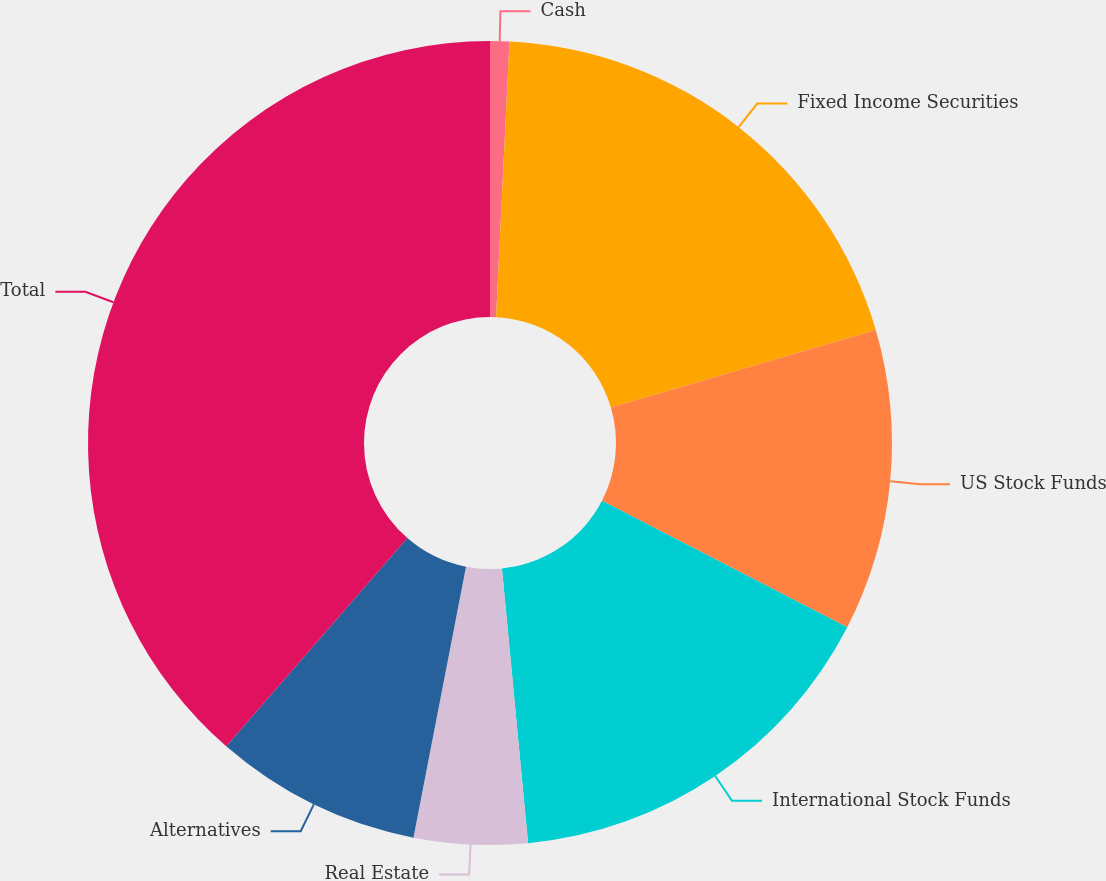Convert chart. <chart><loc_0><loc_0><loc_500><loc_500><pie_chart><fcel>Cash<fcel>Fixed Income Securities<fcel>US Stock Funds<fcel>International Stock Funds<fcel>Real Estate<fcel>Alternatives<fcel>Total<nl><fcel>0.77%<fcel>19.69%<fcel>12.12%<fcel>15.91%<fcel>4.56%<fcel>8.34%<fcel>38.61%<nl></chart> 